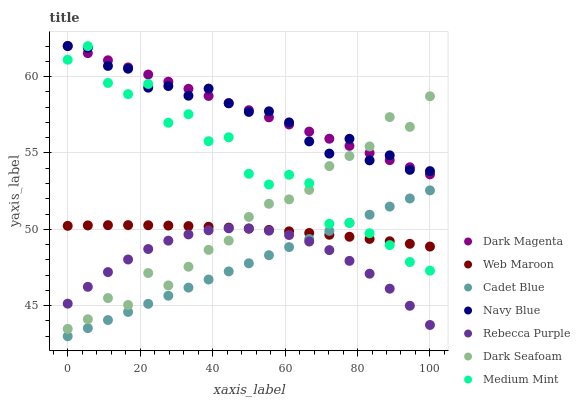Does Cadet Blue have the minimum area under the curve?
Answer yes or no. Yes. Does Dark Magenta have the maximum area under the curve?
Answer yes or no. Yes. Does Dark Magenta have the minimum area under the curve?
Answer yes or no. No. Does Cadet Blue have the maximum area under the curve?
Answer yes or no. No. Is Cadet Blue the smoothest?
Answer yes or no. Yes. Is Medium Mint the roughest?
Answer yes or no. Yes. Is Dark Magenta the smoothest?
Answer yes or no. No. Is Dark Magenta the roughest?
Answer yes or no. No. Does Cadet Blue have the lowest value?
Answer yes or no. Yes. Does Dark Magenta have the lowest value?
Answer yes or no. No. Does Navy Blue have the highest value?
Answer yes or no. Yes. Does Cadet Blue have the highest value?
Answer yes or no. No. Is Cadet Blue less than Dark Seafoam?
Answer yes or no. Yes. Is Dark Seafoam greater than Cadet Blue?
Answer yes or no. Yes. Does Medium Mint intersect Cadet Blue?
Answer yes or no. Yes. Is Medium Mint less than Cadet Blue?
Answer yes or no. No. Is Medium Mint greater than Cadet Blue?
Answer yes or no. No. Does Cadet Blue intersect Dark Seafoam?
Answer yes or no. No. 